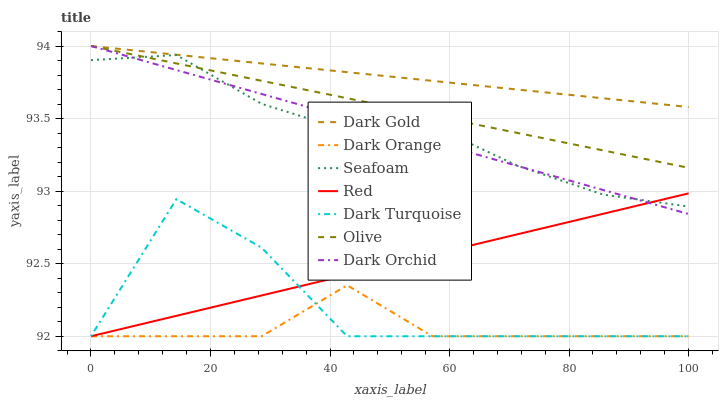Does Dark Orange have the minimum area under the curve?
Answer yes or no. Yes. Does Dark Gold have the maximum area under the curve?
Answer yes or no. Yes. Does Dark Turquoise have the minimum area under the curve?
Answer yes or no. No. Does Dark Turquoise have the maximum area under the curve?
Answer yes or no. No. Is Red the smoothest?
Answer yes or no. Yes. Is Dark Turquoise the roughest?
Answer yes or no. Yes. Is Dark Gold the smoothest?
Answer yes or no. No. Is Dark Gold the roughest?
Answer yes or no. No. Does Dark Gold have the lowest value?
Answer yes or no. No. Does Dark Turquoise have the highest value?
Answer yes or no. No. Is Dark Orange less than Dark Orchid?
Answer yes or no. Yes. Is Dark Gold greater than Seafoam?
Answer yes or no. Yes. Does Dark Orange intersect Dark Orchid?
Answer yes or no. No. 